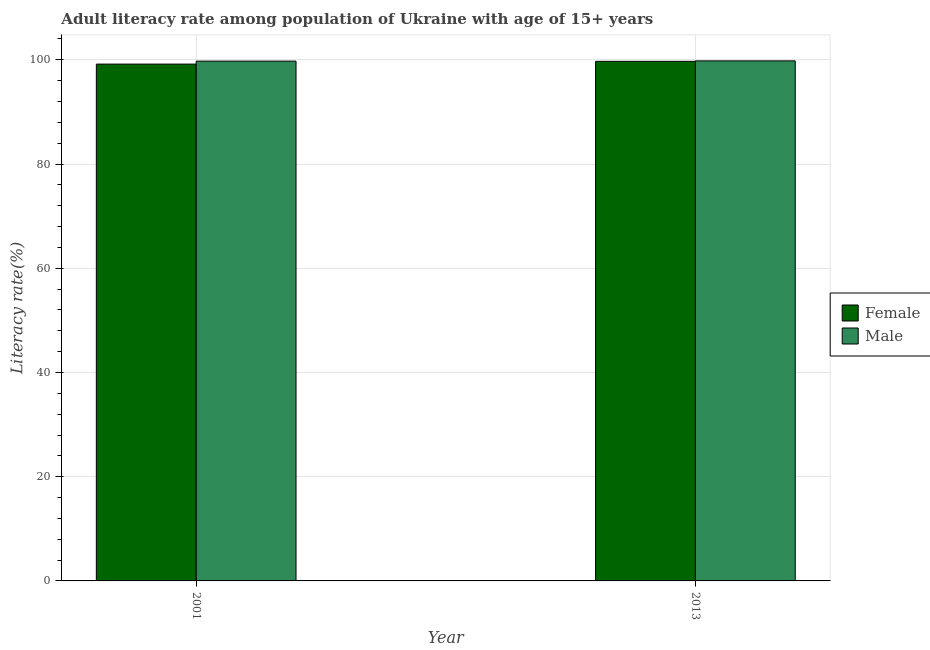How many different coloured bars are there?
Provide a short and direct response. 2. Are the number of bars per tick equal to the number of legend labels?
Make the answer very short. Yes. How many bars are there on the 2nd tick from the left?
Your response must be concise. 2. How many bars are there on the 1st tick from the right?
Provide a short and direct response. 2. What is the label of the 2nd group of bars from the left?
Give a very brief answer. 2013. In how many cases, is the number of bars for a given year not equal to the number of legend labels?
Make the answer very short. 0. What is the male adult literacy rate in 2013?
Your answer should be compact. 99.79. Across all years, what is the maximum male adult literacy rate?
Offer a terse response. 99.79. Across all years, what is the minimum female adult literacy rate?
Provide a short and direct response. 99.17. In which year was the male adult literacy rate maximum?
Give a very brief answer. 2013. In which year was the male adult literacy rate minimum?
Your response must be concise. 2001. What is the total female adult literacy rate in the graph?
Your answer should be compact. 198.87. What is the difference between the female adult literacy rate in 2001 and that in 2013?
Keep it short and to the point. -0.53. What is the difference between the male adult literacy rate in 2001 and the female adult literacy rate in 2013?
Provide a short and direct response. -0.05. What is the average male adult literacy rate per year?
Provide a succinct answer. 99.77. In how many years, is the male adult literacy rate greater than 56 %?
Your answer should be very brief. 2. What is the ratio of the male adult literacy rate in 2001 to that in 2013?
Give a very brief answer. 1. Is the male adult literacy rate in 2001 less than that in 2013?
Offer a very short reply. Yes. What does the 1st bar from the left in 2001 represents?
Offer a very short reply. Female. What does the 1st bar from the right in 2001 represents?
Keep it short and to the point. Male. How many bars are there?
Keep it short and to the point. 4. What is the difference between two consecutive major ticks on the Y-axis?
Your response must be concise. 20. Does the graph contain grids?
Give a very brief answer. Yes. How many legend labels are there?
Provide a succinct answer. 2. What is the title of the graph?
Provide a succinct answer. Adult literacy rate among population of Ukraine with age of 15+ years. What is the label or title of the X-axis?
Ensure brevity in your answer.  Year. What is the label or title of the Y-axis?
Provide a succinct answer. Literacy rate(%). What is the Literacy rate(%) in Female in 2001?
Your response must be concise. 99.17. What is the Literacy rate(%) of Male in 2001?
Provide a succinct answer. 99.74. What is the Literacy rate(%) in Female in 2013?
Offer a terse response. 99.7. What is the Literacy rate(%) in Male in 2013?
Offer a very short reply. 99.79. Across all years, what is the maximum Literacy rate(%) in Female?
Ensure brevity in your answer.  99.7. Across all years, what is the maximum Literacy rate(%) of Male?
Make the answer very short. 99.79. Across all years, what is the minimum Literacy rate(%) in Female?
Your response must be concise. 99.17. Across all years, what is the minimum Literacy rate(%) of Male?
Keep it short and to the point. 99.74. What is the total Literacy rate(%) of Female in the graph?
Ensure brevity in your answer.  198.87. What is the total Literacy rate(%) of Male in the graph?
Provide a succinct answer. 199.53. What is the difference between the Literacy rate(%) of Female in 2001 and that in 2013?
Offer a very short reply. -0.53. What is the difference between the Literacy rate(%) of Male in 2001 and that in 2013?
Give a very brief answer. -0.05. What is the difference between the Literacy rate(%) in Female in 2001 and the Literacy rate(%) in Male in 2013?
Offer a very short reply. -0.62. What is the average Literacy rate(%) in Female per year?
Make the answer very short. 99.44. What is the average Literacy rate(%) of Male per year?
Your answer should be compact. 99.77. In the year 2001, what is the difference between the Literacy rate(%) in Female and Literacy rate(%) in Male?
Offer a very short reply. -0.57. In the year 2013, what is the difference between the Literacy rate(%) of Female and Literacy rate(%) of Male?
Ensure brevity in your answer.  -0.09. What is the ratio of the Literacy rate(%) of Female in 2001 to that in 2013?
Provide a short and direct response. 0.99. What is the difference between the highest and the second highest Literacy rate(%) in Female?
Your answer should be very brief. 0.53. What is the difference between the highest and the second highest Literacy rate(%) of Male?
Give a very brief answer. 0.05. What is the difference between the highest and the lowest Literacy rate(%) in Female?
Provide a succinct answer. 0.53. What is the difference between the highest and the lowest Literacy rate(%) in Male?
Offer a terse response. 0.05. 